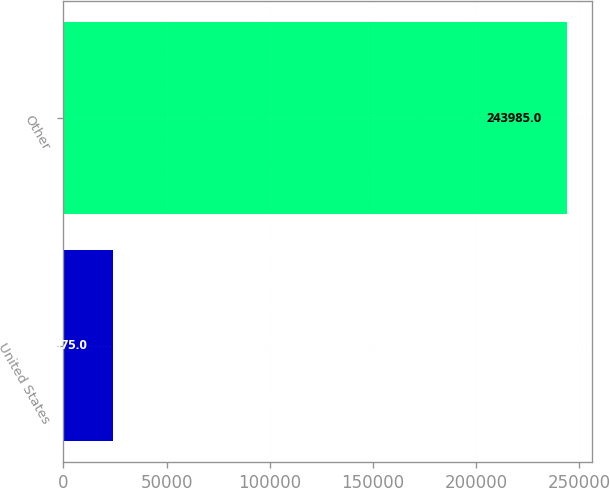Convert chart. <chart><loc_0><loc_0><loc_500><loc_500><bar_chart><fcel>United States<fcel>Other<nl><fcel>23875<fcel>243985<nl></chart> 